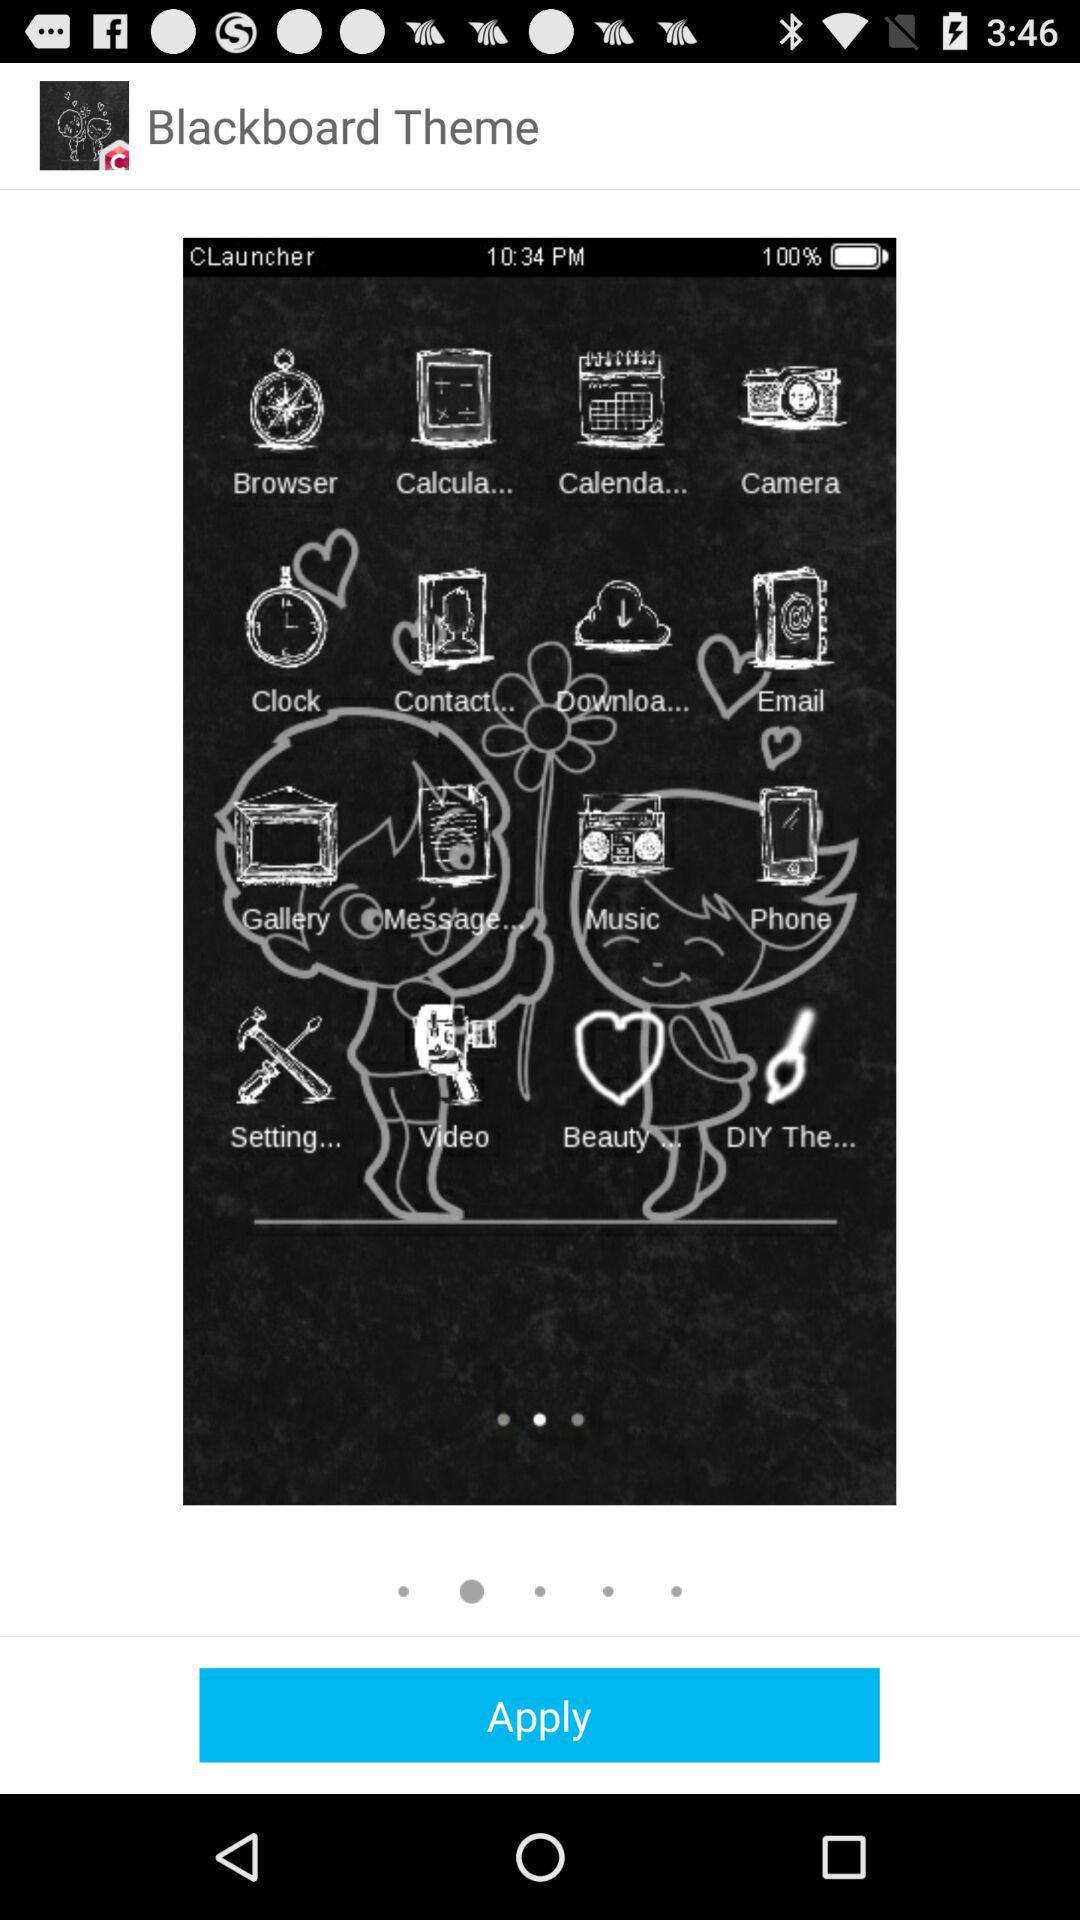What is the name of the application? The name of the application is "Blackboard Theme". 